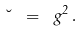Convert formula to latex. <formula><loc_0><loc_0><loc_500><loc_500>\lambda \ = \ g ^ { 2 } \, .</formula> 